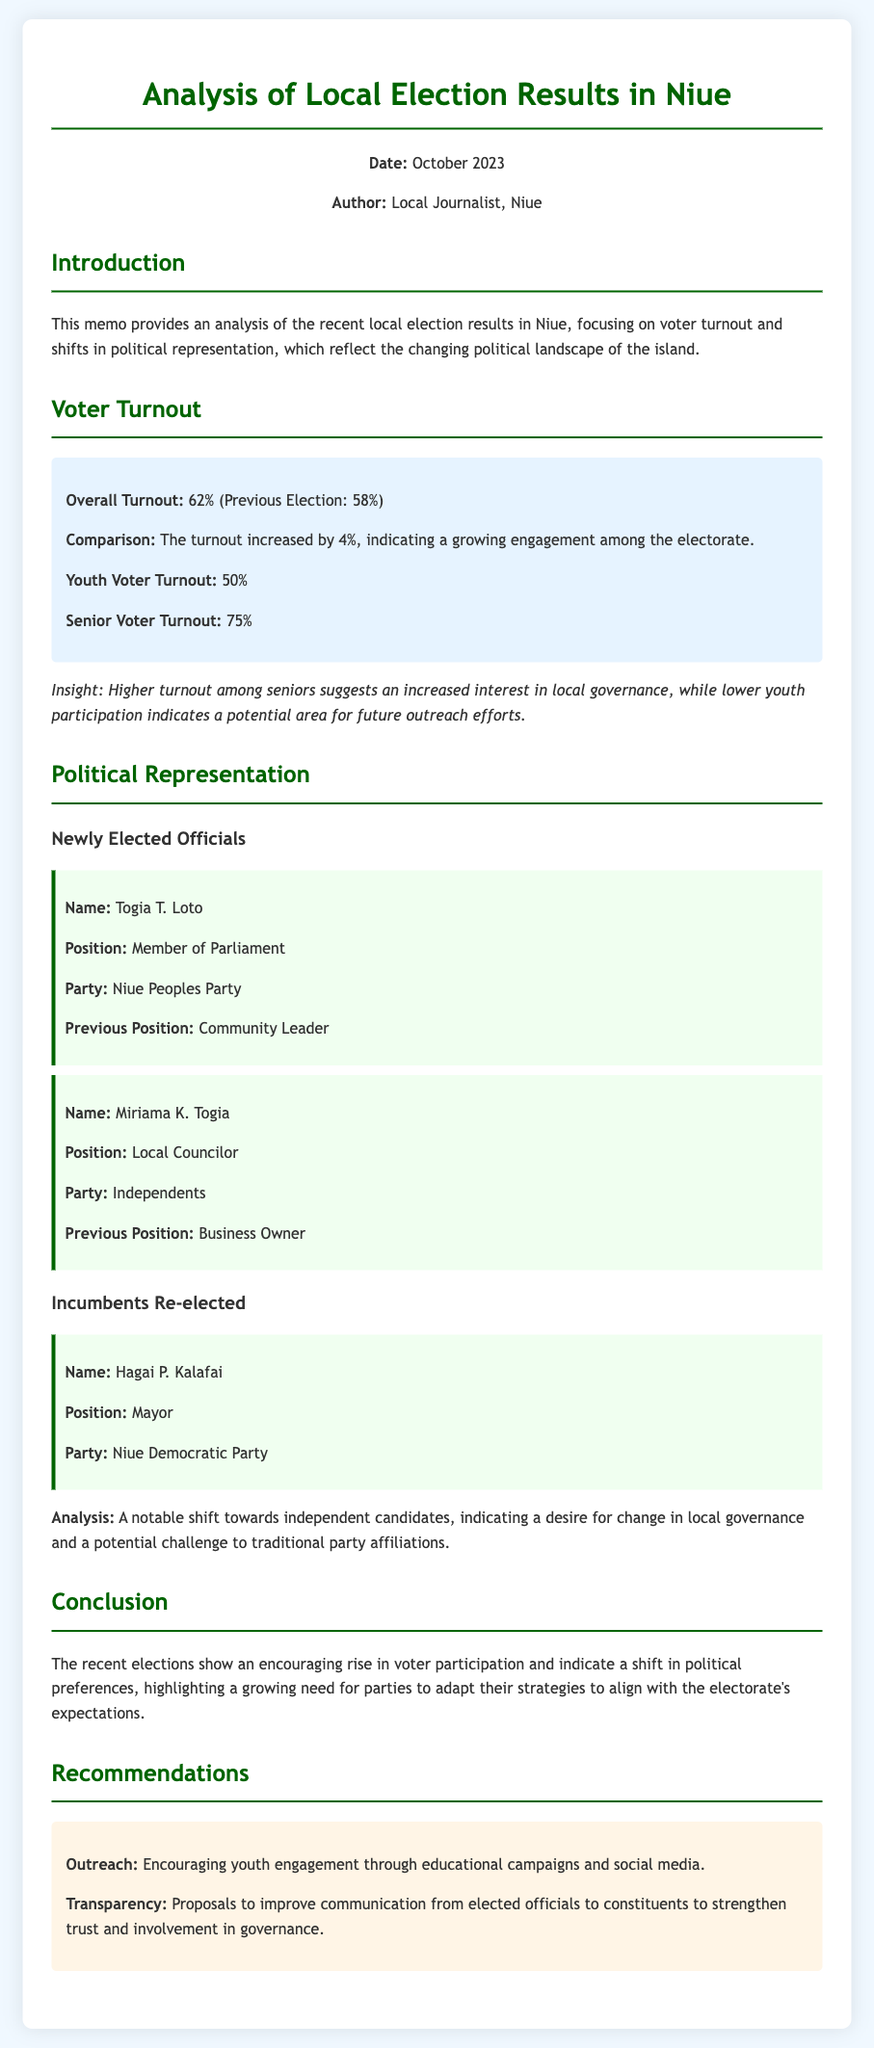what is the overall voter turnout? The document states the overall voter turnout for the recent election is 62%.
Answer: 62% what was the previous election's voter turnout percentage? The document mentions the previous election's voter turnout was 58%.
Answer: 58% who is the newly elected Member of Parliament? The document lists Togia T. Loto as the newly elected Member of Parliament.
Answer: Togia T. Loto which party did Guenther W. Taumaunu represent when re-elected? The document indicates that Hagai P. Kalafai is the Mayor from the Niue Democratic Party.
Answer: Niue Democratic Party what was the youth voter turnout percentage? The memo specifies the youth voter turnout at 50%.
Answer: 50% what does the analysis of political representation indicate? The document states there is a notable shift towards independent candidates.
Answer: Shift towards independent candidates what is one recommendation for improving youth engagement? The document recommends encouraging youth engagement through educational campaigns.
Answer: Educational campaigns what conclusion is drawn about the election's impact on party strategies? The conclusion emphasizes the need for parties to adapt their strategies to align with electorate expectations.
Answer: Align with electorate expectations what is the date of the document? The memo indicates that the date of the document is October 2023.
Answer: October 2023 